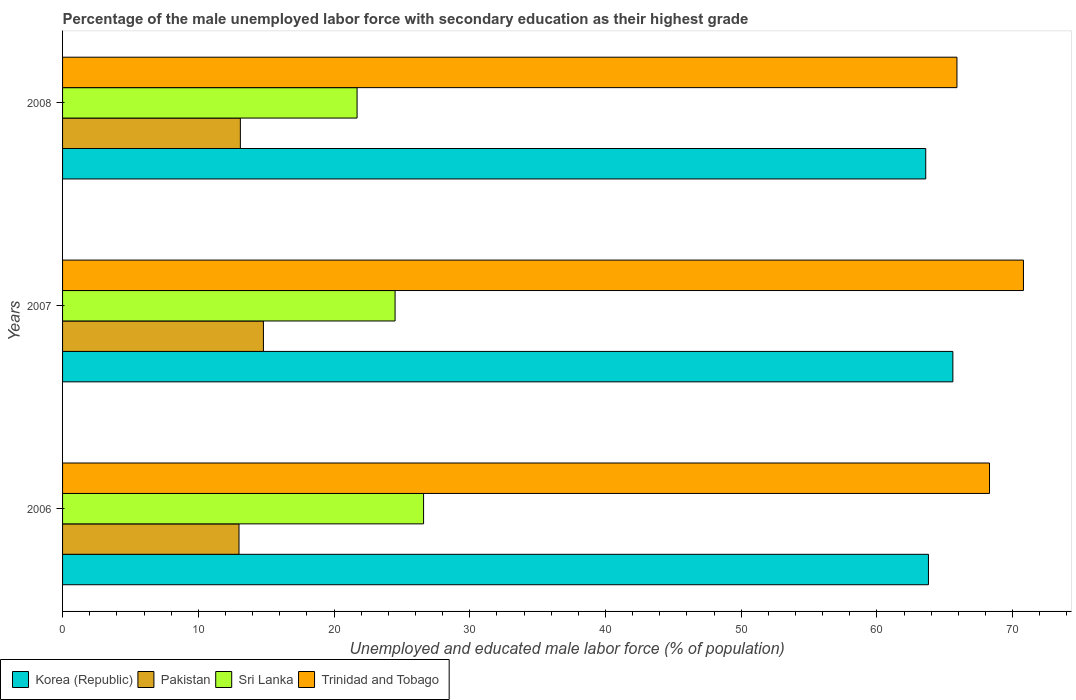Are the number of bars per tick equal to the number of legend labels?
Your response must be concise. Yes. How many bars are there on the 1st tick from the top?
Offer a terse response. 4. How many bars are there on the 1st tick from the bottom?
Provide a succinct answer. 4. What is the label of the 2nd group of bars from the top?
Your response must be concise. 2007. In how many cases, is the number of bars for a given year not equal to the number of legend labels?
Your response must be concise. 0. What is the percentage of the unemployed male labor force with secondary education in Sri Lanka in 2007?
Offer a terse response. 24.5. Across all years, what is the maximum percentage of the unemployed male labor force with secondary education in Korea (Republic)?
Your response must be concise. 65.6. Across all years, what is the minimum percentage of the unemployed male labor force with secondary education in Korea (Republic)?
Provide a succinct answer. 63.6. In which year was the percentage of the unemployed male labor force with secondary education in Trinidad and Tobago minimum?
Provide a short and direct response. 2008. What is the total percentage of the unemployed male labor force with secondary education in Sri Lanka in the graph?
Provide a short and direct response. 72.8. What is the difference between the percentage of the unemployed male labor force with secondary education in Korea (Republic) in 2006 and that in 2008?
Your answer should be very brief. 0.2. What is the difference between the percentage of the unemployed male labor force with secondary education in Pakistan in 2006 and the percentage of the unemployed male labor force with secondary education in Trinidad and Tobago in 2007?
Provide a short and direct response. -57.8. What is the average percentage of the unemployed male labor force with secondary education in Pakistan per year?
Give a very brief answer. 13.63. In the year 2006, what is the difference between the percentage of the unemployed male labor force with secondary education in Trinidad and Tobago and percentage of the unemployed male labor force with secondary education in Korea (Republic)?
Your answer should be compact. 4.5. What is the ratio of the percentage of the unemployed male labor force with secondary education in Trinidad and Tobago in 2006 to that in 2008?
Make the answer very short. 1.04. Is the difference between the percentage of the unemployed male labor force with secondary education in Trinidad and Tobago in 2006 and 2007 greater than the difference between the percentage of the unemployed male labor force with secondary education in Korea (Republic) in 2006 and 2007?
Provide a succinct answer. No. What is the difference between the highest and the second highest percentage of the unemployed male labor force with secondary education in Trinidad and Tobago?
Your response must be concise. 2.5. What is the difference between the highest and the lowest percentage of the unemployed male labor force with secondary education in Pakistan?
Make the answer very short. 1.8. What does the 3rd bar from the bottom in 2007 represents?
Your answer should be very brief. Sri Lanka. Is it the case that in every year, the sum of the percentage of the unemployed male labor force with secondary education in Trinidad and Tobago and percentage of the unemployed male labor force with secondary education in Korea (Republic) is greater than the percentage of the unemployed male labor force with secondary education in Sri Lanka?
Make the answer very short. Yes. Are the values on the major ticks of X-axis written in scientific E-notation?
Provide a short and direct response. No. Does the graph contain any zero values?
Provide a short and direct response. No. Does the graph contain grids?
Your response must be concise. No. How are the legend labels stacked?
Provide a succinct answer. Horizontal. What is the title of the graph?
Ensure brevity in your answer.  Percentage of the male unemployed labor force with secondary education as their highest grade. What is the label or title of the X-axis?
Offer a terse response. Unemployed and educated male labor force (% of population). What is the Unemployed and educated male labor force (% of population) in Korea (Republic) in 2006?
Ensure brevity in your answer.  63.8. What is the Unemployed and educated male labor force (% of population) in Sri Lanka in 2006?
Offer a terse response. 26.6. What is the Unemployed and educated male labor force (% of population) in Trinidad and Tobago in 2006?
Give a very brief answer. 68.3. What is the Unemployed and educated male labor force (% of population) of Korea (Republic) in 2007?
Provide a succinct answer. 65.6. What is the Unemployed and educated male labor force (% of population) in Pakistan in 2007?
Offer a very short reply. 14.8. What is the Unemployed and educated male labor force (% of population) of Trinidad and Tobago in 2007?
Ensure brevity in your answer.  70.8. What is the Unemployed and educated male labor force (% of population) in Korea (Republic) in 2008?
Provide a succinct answer. 63.6. What is the Unemployed and educated male labor force (% of population) of Pakistan in 2008?
Offer a terse response. 13.1. What is the Unemployed and educated male labor force (% of population) of Sri Lanka in 2008?
Provide a succinct answer. 21.7. What is the Unemployed and educated male labor force (% of population) of Trinidad and Tobago in 2008?
Keep it short and to the point. 65.9. Across all years, what is the maximum Unemployed and educated male labor force (% of population) of Korea (Republic)?
Keep it short and to the point. 65.6. Across all years, what is the maximum Unemployed and educated male labor force (% of population) in Pakistan?
Provide a short and direct response. 14.8. Across all years, what is the maximum Unemployed and educated male labor force (% of population) in Sri Lanka?
Your answer should be very brief. 26.6. Across all years, what is the maximum Unemployed and educated male labor force (% of population) of Trinidad and Tobago?
Your response must be concise. 70.8. Across all years, what is the minimum Unemployed and educated male labor force (% of population) of Korea (Republic)?
Make the answer very short. 63.6. Across all years, what is the minimum Unemployed and educated male labor force (% of population) in Sri Lanka?
Keep it short and to the point. 21.7. Across all years, what is the minimum Unemployed and educated male labor force (% of population) of Trinidad and Tobago?
Your answer should be compact. 65.9. What is the total Unemployed and educated male labor force (% of population) of Korea (Republic) in the graph?
Ensure brevity in your answer.  193. What is the total Unemployed and educated male labor force (% of population) of Pakistan in the graph?
Your answer should be very brief. 40.9. What is the total Unemployed and educated male labor force (% of population) in Sri Lanka in the graph?
Ensure brevity in your answer.  72.8. What is the total Unemployed and educated male labor force (% of population) of Trinidad and Tobago in the graph?
Make the answer very short. 205. What is the difference between the Unemployed and educated male labor force (% of population) in Pakistan in 2006 and that in 2007?
Your answer should be very brief. -1.8. What is the difference between the Unemployed and educated male labor force (% of population) in Sri Lanka in 2006 and that in 2007?
Offer a very short reply. 2.1. What is the difference between the Unemployed and educated male labor force (% of population) of Sri Lanka in 2007 and that in 2008?
Your answer should be compact. 2.8. What is the difference between the Unemployed and educated male labor force (% of population) of Korea (Republic) in 2006 and the Unemployed and educated male labor force (% of population) of Pakistan in 2007?
Your response must be concise. 49. What is the difference between the Unemployed and educated male labor force (% of population) of Korea (Republic) in 2006 and the Unemployed and educated male labor force (% of population) of Sri Lanka in 2007?
Your answer should be very brief. 39.3. What is the difference between the Unemployed and educated male labor force (% of population) in Korea (Republic) in 2006 and the Unemployed and educated male labor force (% of population) in Trinidad and Tobago in 2007?
Provide a short and direct response. -7. What is the difference between the Unemployed and educated male labor force (% of population) in Pakistan in 2006 and the Unemployed and educated male labor force (% of population) in Trinidad and Tobago in 2007?
Offer a terse response. -57.8. What is the difference between the Unemployed and educated male labor force (% of population) in Sri Lanka in 2006 and the Unemployed and educated male labor force (% of population) in Trinidad and Tobago in 2007?
Give a very brief answer. -44.2. What is the difference between the Unemployed and educated male labor force (% of population) of Korea (Republic) in 2006 and the Unemployed and educated male labor force (% of population) of Pakistan in 2008?
Offer a very short reply. 50.7. What is the difference between the Unemployed and educated male labor force (% of population) of Korea (Republic) in 2006 and the Unemployed and educated male labor force (% of population) of Sri Lanka in 2008?
Give a very brief answer. 42.1. What is the difference between the Unemployed and educated male labor force (% of population) of Korea (Republic) in 2006 and the Unemployed and educated male labor force (% of population) of Trinidad and Tobago in 2008?
Keep it short and to the point. -2.1. What is the difference between the Unemployed and educated male labor force (% of population) in Pakistan in 2006 and the Unemployed and educated male labor force (% of population) in Trinidad and Tobago in 2008?
Give a very brief answer. -52.9. What is the difference between the Unemployed and educated male labor force (% of population) in Sri Lanka in 2006 and the Unemployed and educated male labor force (% of population) in Trinidad and Tobago in 2008?
Offer a terse response. -39.3. What is the difference between the Unemployed and educated male labor force (% of population) of Korea (Republic) in 2007 and the Unemployed and educated male labor force (% of population) of Pakistan in 2008?
Your answer should be very brief. 52.5. What is the difference between the Unemployed and educated male labor force (% of population) in Korea (Republic) in 2007 and the Unemployed and educated male labor force (% of population) in Sri Lanka in 2008?
Your answer should be compact. 43.9. What is the difference between the Unemployed and educated male labor force (% of population) in Korea (Republic) in 2007 and the Unemployed and educated male labor force (% of population) in Trinidad and Tobago in 2008?
Offer a very short reply. -0.3. What is the difference between the Unemployed and educated male labor force (% of population) in Pakistan in 2007 and the Unemployed and educated male labor force (% of population) in Trinidad and Tobago in 2008?
Offer a very short reply. -51.1. What is the difference between the Unemployed and educated male labor force (% of population) in Sri Lanka in 2007 and the Unemployed and educated male labor force (% of population) in Trinidad and Tobago in 2008?
Ensure brevity in your answer.  -41.4. What is the average Unemployed and educated male labor force (% of population) in Korea (Republic) per year?
Give a very brief answer. 64.33. What is the average Unemployed and educated male labor force (% of population) in Pakistan per year?
Keep it short and to the point. 13.63. What is the average Unemployed and educated male labor force (% of population) in Sri Lanka per year?
Keep it short and to the point. 24.27. What is the average Unemployed and educated male labor force (% of population) in Trinidad and Tobago per year?
Offer a terse response. 68.33. In the year 2006, what is the difference between the Unemployed and educated male labor force (% of population) of Korea (Republic) and Unemployed and educated male labor force (% of population) of Pakistan?
Give a very brief answer. 50.8. In the year 2006, what is the difference between the Unemployed and educated male labor force (% of population) in Korea (Republic) and Unemployed and educated male labor force (% of population) in Sri Lanka?
Your answer should be compact. 37.2. In the year 2006, what is the difference between the Unemployed and educated male labor force (% of population) of Pakistan and Unemployed and educated male labor force (% of population) of Trinidad and Tobago?
Offer a terse response. -55.3. In the year 2006, what is the difference between the Unemployed and educated male labor force (% of population) in Sri Lanka and Unemployed and educated male labor force (% of population) in Trinidad and Tobago?
Make the answer very short. -41.7. In the year 2007, what is the difference between the Unemployed and educated male labor force (% of population) in Korea (Republic) and Unemployed and educated male labor force (% of population) in Pakistan?
Provide a short and direct response. 50.8. In the year 2007, what is the difference between the Unemployed and educated male labor force (% of population) in Korea (Republic) and Unemployed and educated male labor force (% of population) in Sri Lanka?
Keep it short and to the point. 41.1. In the year 2007, what is the difference between the Unemployed and educated male labor force (% of population) in Pakistan and Unemployed and educated male labor force (% of population) in Sri Lanka?
Your answer should be compact. -9.7. In the year 2007, what is the difference between the Unemployed and educated male labor force (% of population) of Pakistan and Unemployed and educated male labor force (% of population) of Trinidad and Tobago?
Your answer should be compact. -56. In the year 2007, what is the difference between the Unemployed and educated male labor force (% of population) in Sri Lanka and Unemployed and educated male labor force (% of population) in Trinidad and Tobago?
Keep it short and to the point. -46.3. In the year 2008, what is the difference between the Unemployed and educated male labor force (% of population) in Korea (Republic) and Unemployed and educated male labor force (% of population) in Pakistan?
Provide a succinct answer. 50.5. In the year 2008, what is the difference between the Unemployed and educated male labor force (% of population) in Korea (Republic) and Unemployed and educated male labor force (% of population) in Sri Lanka?
Your answer should be compact. 41.9. In the year 2008, what is the difference between the Unemployed and educated male labor force (% of population) of Korea (Republic) and Unemployed and educated male labor force (% of population) of Trinidad and Tobago?
Keep it short and to the point. -2.3. In the year 2008, what is the difference between the Unemployed and educated male labor force (% of population) of Pakistan and Unemployed and educated male labor force (% of population) of Sri Lanka?
Your answer should be compact. -8.6. In the year 2008, what is the difference between the Unemployed and educated male labor force (% of population) in Pakistan and Unemployed and educated male labor force (% of population) in Trinidad and Tobago?
Make the answer very short. -52.8. In the year 2008, what is the difference between the Unemployed and educated male labor force (% of population) in Sri Lanka and Unemployed and educated male labor force (% of population) in Trinidad and Tobago?
Provide a succinct answer. -44.2. What is the ratio of the Unemployed and educated male labor force (% of population) in Korea (Republic) in 2006 to that in 2007?
Ensure brevity in your answer.  0.97. What is the ratio of the Unemployed and educated male labor force (% of population) in Pakistan in 2006 to that in 2007?
Give a very brief answer. 0.88. What is the ratio of the Unemployed and educated male labor force (% of population) of Sri Lanka in 2006 to that in 2007?
Ensure brevity in your answer.  1.09. What is the ratio of the Unemployed and educated male labor force (% of population) in Trinidad and Tobago in 2006 to that in 2007?
Give a very brief answer. 0.96. What is the ratio of the Unemployed and educated male labor force (% of population) of Korea (Republic) in 2006 to that in 2008?
Make the answer very short. 1. What is the ratio of the Unemployed and educated male labor force (% of population) of Sri Lanka in 2006 to that in 2008?
Make the answer very short. 1.23. What is the ratio of the Unemployed and educated male labor force (% of population) of Trinidad and Tobago in 2006 to that in 2008?
Keep it short and to the point. 1.04. What is the ratio of the Unemployed and educated male labor force (% of population) of Korea (Republic) in 2007 to that in 2008?
Make the answer very short. 1.03. What is the ratio of the Unemployed and educated male labor force (% of population) in Pakistan in 2007 to that in 2008?
Your answer should be compact. 1.13. What is the ratio of the Unemployed and educated male labor force (% of population) of Sri Lanka in 2007 to that in 2008?
Your answer should be very brief. 1.13. What is the ratio of the Unemployed and educated male labor force (% of population) in Trinidad and Tobago in 2007 to that in 2008?
Your answer should be compact. 1.07. What is the difference between the highest and the second highest Unemployed and educated male labor force (% of population) in Trinidad and Tobago?
Your answer should be very brief. 2.5. What is the difference between the highest and the lowest Unemployed and educated male labor force (% of population) of Pakistan?
Your response must be concise. 1.8. What is the difference between the highest and the lowest Unemployed and educated male labor force (% of population) in Sri Lanka?
Give a very brief answer. 4.9. 